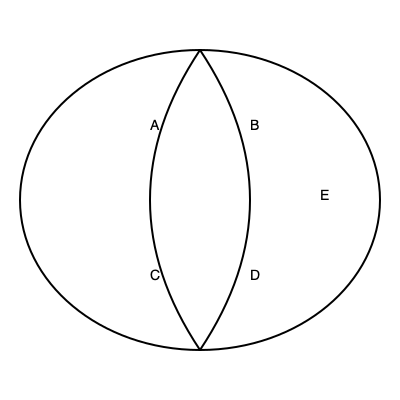Using the labeled brain diagram, identify the region most commonly targeted by mood stabilizers such as lithium in the treatment of bipolar disorder. To answer this question, let's consider the regions labeled in the brain diagram and their functions:

1. Region A: This appears to be the frontal lobe, responsible for executive functions, decision-making, and personality.

2. Region B: This represents the parietal lobe, involved in sensory processing and spatial awareness.

3. Region C: This is likely the temporal lobe, associated with memory, language, and auditory processing.

4. Region D: This appears to be the occipital lobe, primarily responsible for visual processing.

5. Region E: This region, located in the center of the brain, represents the limbic system, which includes structures like the hypothalamus, amygdala, and hippocampus.

Mood stabilizers, particularly lithium, are known to primarily affect the limbic system, which plays a crucial role in regulating emotions and mood. The limbic system, especially the amygdala and hippocampus, has been implicated in the pathophysiology of bipolar disorder.

Research has shown that lithium can modulate neurotransmitter systems and affect signaling pathways within the limbic structures, leading to its mood-stabilizing effects. It has been observed to normalize the hyperactivity often seen in the limbic system of individuals with bipolar disorder.

Therefore, the region most commonly targeted by mood stabilizers like lithium in the treatment of bipolar disorder is the limbic system, represented by Region E in the diagram.
Answer: E (Limbic system) 